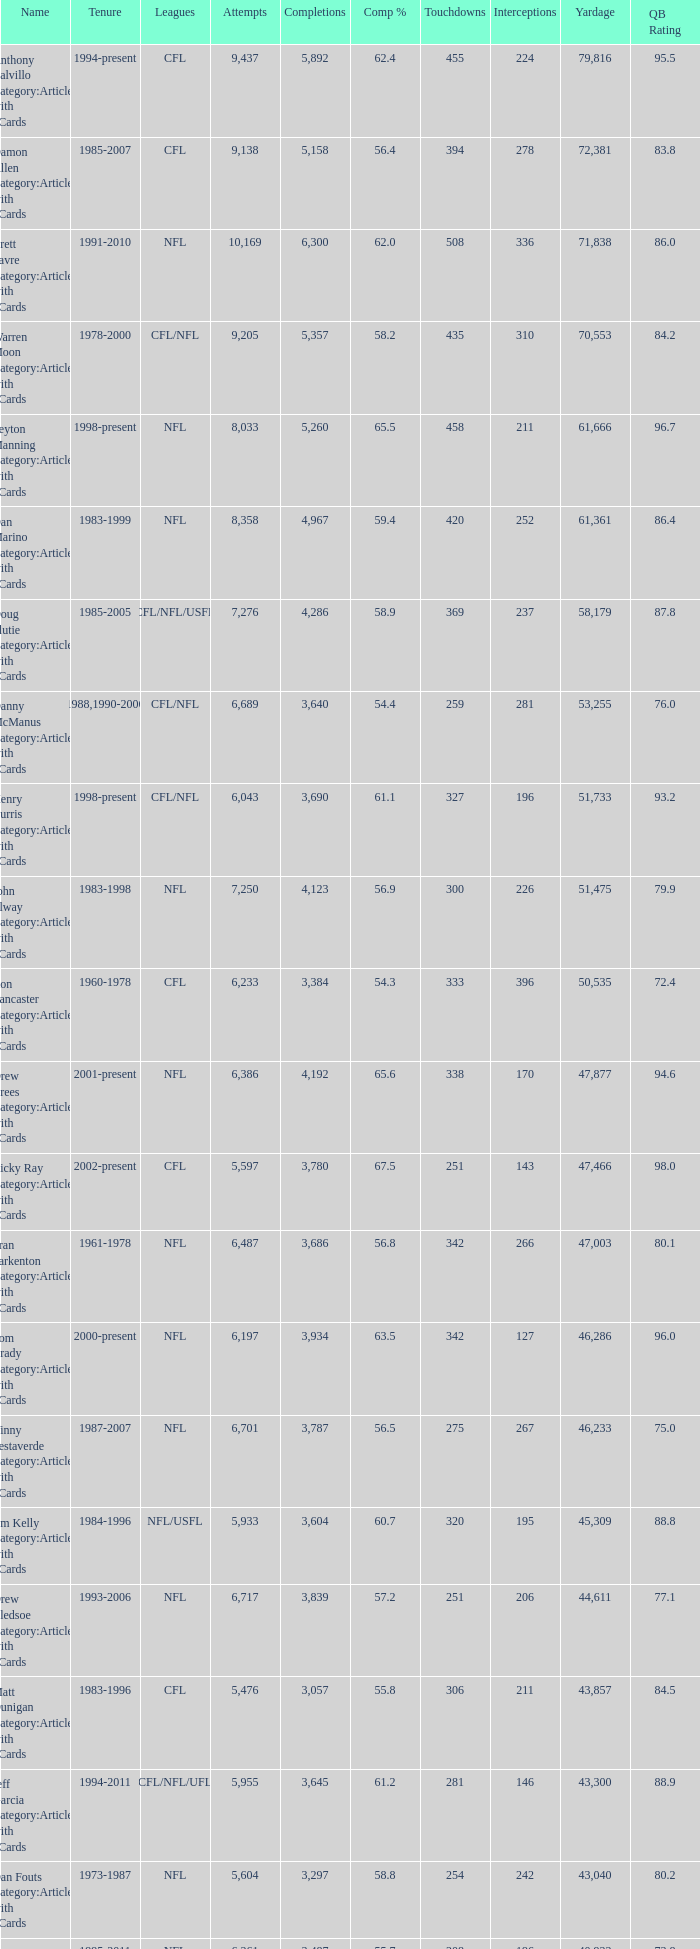What is the number of interceptions with less than 3,487 completions , more than 40,551 yardage, and the comp % is 55.8? 211.0. 